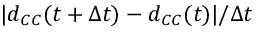Convert formula to latex. <formula><loc_0><loc_0><loc_500><loc_500>| d _ { C C } ( t + \Delta t ) - d _ { C C } ( t ) | / \Delta t</formula> 